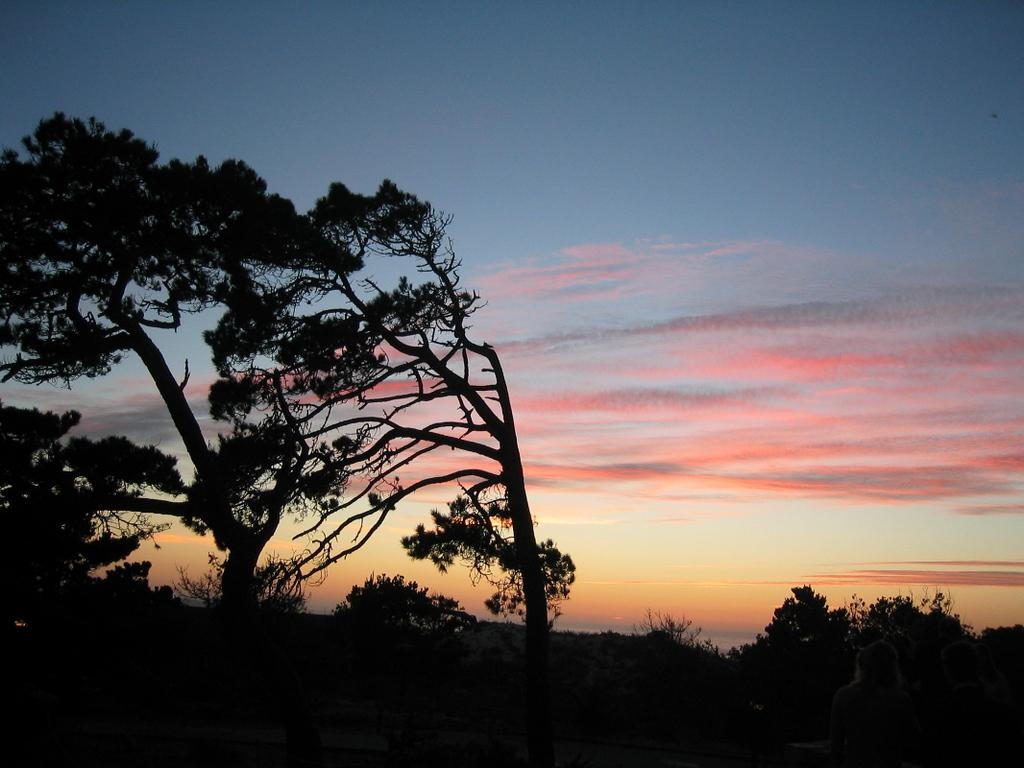What type of vegetation can be seen in the image? There are trees in the image. What can be seen in the sky in the image? There are clouds in the image. What type of science experiment is being conducted in the image? There is no science experiment present in the image; it only features trees and clouds. How do the trees play a role in the image? The trees do not play a role in the image; they are simply a part of the natural scenery. 